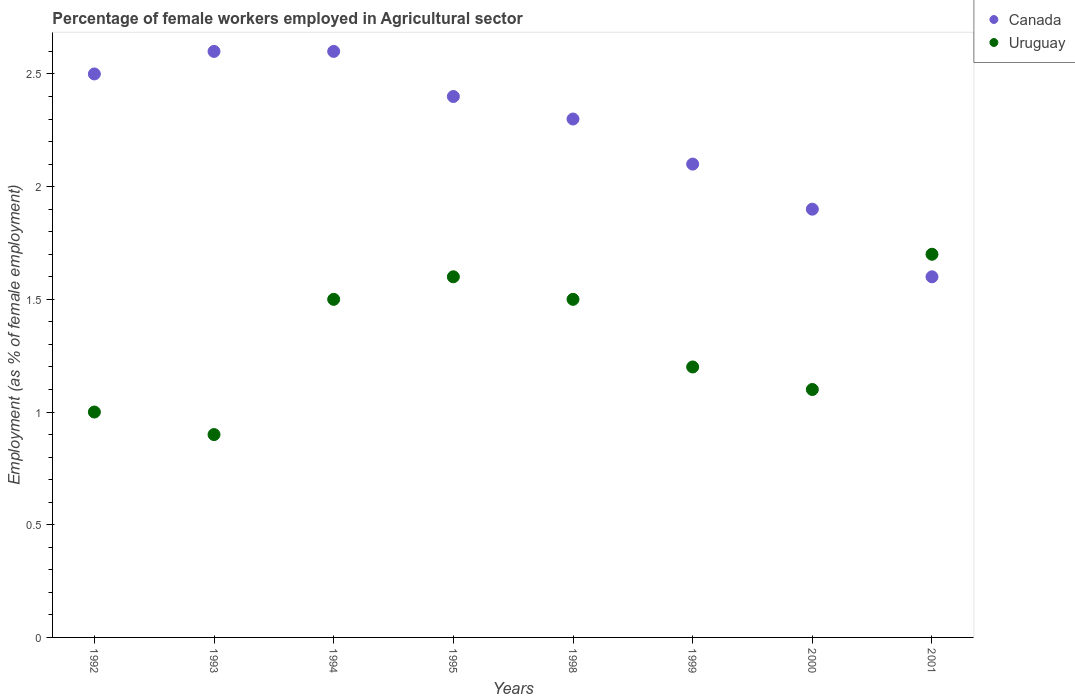What is the percentage of females employed in Agricultural sector in Uruguay in 1992?
Provide a succinct answer. 1. Across all years, what is the maximum percentage of females employed in Agricultural sector in Uruguay?
Give a very brief answer. 1.7. Across all years, what is the minimum percentage of females employed in Agricultural sector in Uruguay?
Give a very brief answer. 0.9. In which year was the percentage of females employed in Agricultural sector in Canada maximum?
Offer a very short reply. 1993. What is the total percentage of females employed in Agricultural sector in Uruguay in the graph?
Make the answer very short. 10.5. What is the difference between the percentage of females employed in Agricultural sector in Uruguay in 1994 and that in 2001?
Ensure brevity in your answer.  -0.2. What is the difference between the percentage of females employed in Agricultural sector in Canada in 1994 and the percentage of females employed in Agricultural sector in Uruguay in 2001?
Keep it short and to the point. 0.9. What is the average percentage of females employed in Agricultural sector in Canada per year?
Your response must be concise. 2.25. In the year 1993, what is the difference between the percentage of females employed in Agricultural sector in Canada and percentage of females employed in Agricultural sector in Uruguay?
Give a very brief answer. 1.7. What is the ratio of the percentage of females employed in Agricultural sector in Canada in 1995 to that in 2000?
Your response must be concise. 1.26. Is the percentage of females employed in Agricultural sector in Uruguay in 1992 less than that in 1995?
Your response must be concise. Yes. Is the difference between the percentage of females employed in Agricultural sector in Canada in 1999 and 2000 greater than the difference between the percentage of females employed in Agricultural sector in Uruguay in 1999 and 2000?
Your answer should be compact. Yes. What is the difference between the highest and the second highest percentage of females employed in Agricultural sector in Canada?
Make the answer very short. 0. What is the difference between the highest and the lowest percentage of females employed in Agricultural sector in Uruguay?
Provide a short and direct response. 0.8. Is the sum of the percentage of females employed in Agricultural sector in Canada in 1999 and 2001 greater than the maximum percentage of females employed in Agricultural sector in Uruguay across all years?
Offer a terse response. Yes. Does the percentage of females employed in Agricultural sector in Uruguay monotonically increase over the years?
Your response must be concise. No. Is the percentage of females employed in Agricultural sector in Canada strictly greater than the percentage of females employed in Agricultural sector in Uruguay over the years?
Offer a terse response. No. How many dotlines are there?
Make the answer very short. 2. Are the values on the major ticks of Y-axis written in scientific E-notation?
Your response must be concise. No. Does the graph contain grids?
Your answer should be very brief. No. Where does the legend appear in the graph?
Your answer should be very brief. Top right. How many legend labels are there?
Provide a short and direct response. 2. How are the legend labels stacked?
Keep it short and to the point. Vertical. What is the title of the graph?
Your response must be concise. Percentage of female workers employed in Agricultural sector. What is the label or title of the Y-axis?
Give a very brief answer. Employment (as % of female employment). What is the Employment (as % of female employment) of Canada in 1993?
Provide a short and direct response. 2.6. What is the Employment (as % of female employment) in Uruguay in 1993?
Provide a succinct answer. 0.9. What is the Employment (as % of female employment) in Canada in 1994?
Your response must be concise. 2.6. What is the Employment (as % of female employment) in Uruguay in 1994?
Your answer should be compact. 1.5. What is the Employment (as % of female employment) of Canada in 1995?
Provide a succinct answer. 2.4. What is the Employment (as % of female employment) of Uruguay in 1995?
Offer a terse response. 1.6. What is the Employment (as % of female employment) of Canada in 1998?
Provide a short and direct response. 2.3. What is the Employment (as % of female employment) of Uruguay in 1998?
Your answer should be compact. 1.5. What is the Employment (as % of female employment) of Canada in 1999?
Make the answer very short. 2.1. What is the Employment (as % of female employment) of Uruguay in 1999?
Provide a short and direct response. 1.2. What is the Employment (as % of female employment) of Canada in 2000?
Your answer should be compact. 1.9. What is the Employment (as % of female employment) in Uruguay in 2000?
Offer a terse response. 1.1. What is the Employment (as % of female employment) of Canada in 2001?
Provide a short and direct response. 1.6. What is the Employment (as % of female employment) in Uruguay in 2001?
Ensure brevity in your answer.  1.7. Across all years, what is the maximum Employment (as % of female employment) in Canada?
Keep it short and to the point. 2.6. Across all years, what is the maximum Employment (as % of female employment) of Uruguay?
Ensure brevity in your answer.  1.7. Across all years, what is the minimum Employment (as % of female employment) of Canada?
Your answer should be compact. 1.6. Across all years, what is the minimum Employment (as % of female employment) in Uruguay?
Your answer should be very brief. 0.9. What is the total Employment (as % of female employment) of Uruguay in the graph?
Give a very brief answer. 10.5. What is the difference between the Employment (as % of female employment) in Uruguay in 1992 and that in 1993?
Your answer should be compact. 0.1. What is the difference between the Employment (as % of female employment) in Uruguay in 1992 and that in 1994?
Keep it short and to the point. -0.5. What is the difference between the Employment (as % of female employment) in Canada in 1992 and that in 1995?
Your answer should be compact. 0.1. What is the difference between the Employment (as % of female employment) in Uruguay in 1992 and that in 1995?
Your answer should be compact. -0.6. What is the difference between the Employment (as % of female employment) of Uruguay in 1992 and that in 1999?
Offer a very short reply. -0.2. What is the difference between the Employment (as % of female employment) of Uruguay in 1992 and that in 2001?
Your answer should be compact. -0.7. What is the difference between the Employment (as % of female employment) in Canada in 1993 and that in 1994?
Your answer should be compact. 0. What is the difference between the Employment (as % of female employment) of Uruguay in 1993 and that in 1994?
Keep it short and to the point. -0.6. What is the difference between the Employment (as % of female employment) of Canada in 1993 and that in 1995?
Keep it short and to the point. 0.2. What is the difference between the Employment (as % of female employment) in Uruguay in 1993 and that in 1995?
Give a very brief answer. -0.7. What is the difference between the Employment (as % of female employment) of Canada in 1993 and that in 1998?
Your answer should be compact. 0.3. What is the difference between the Employment (as % of female employment) of Canada in 1993 and that in 1999?
Offer a very short reply. 0.5. What is the difference between the Employment (as % of female employment) of Canada in 1993 and that in 2001?
Ensure brevity in your answer.  1. What is the difference between the Employment (as % of female employment) of Canada in 1994 and that in 1995?
Keep it short and to the point. 0.2. What is the difference between the Employment (as % of female employment) of Uruguay in 1994 and that in 1995?
Provide a short and direct response. -0.1. What is the difference between the Employment (as % of female employment) of Uruguay in 1994 and that in 1998?
Your answer should be very brief. 0. What is the difference between the Employment (as % of female employment) in Uruguay in 1994 and that in 1999?
Your response must be concise. 0.3. What is the difference between the Employment (as % of female employment) in Canada in 1994 and that in 2000?
Keep it short and to the point. 0.7. What is the difference between the Employment (as % of female employment) in Uruguay in 1994 and that in 2000?
Provide a short and direct response. 0.4. What is the difference between the Employment (as % of female employment) in Canada in 1995 and that in 1999?
Provide a short and direct response. 0.3. What is the difference between the Employment (as % of female employment) of Uruguay in 1995 and that in 1999?
Ensure brevity in your answer.  0.4. What is the difference between the Employment (as % of female employment) in Uruguay in 1995 and that in 2001?
Offer a terse response. -0.1. What is the difference between the Employment (as % of female employment) of Canada in 1998 and that in 1999?
Give a very brief answer. 0.2. What is the difference between the Employment (as % of female employment) of Uruguay in 1998 and that in 1999?
Your answer should be compact. 0.3. What is the difference between the Employment (as % of female employment) in Uruguay in 1998 and that in 2001?
Provide a succinct answer. -0.2. What is the difference between the Employment (as % of female employment) in Canada in 1999 and that in 2000?
Your answer should be compact. 0.2. What is the difference between the Employment (as % of female employment) of Uruguay in 1999 and that in 2000?
Your response must be concise. 0.1. What is the difference between the Employment (as % of female employment) in Canada in 1999 and that in 2001?
Give a very brief answer. 0.5. What is the difference between the Employment (as % of female employment) of Uruguay in 1999 and that in 2001?
Offer a very short reply. -0.5. What is the difference between the Employment (as % of female employment) of Canada in 2000 and that in 2001?
Provide a succinct answer. 0.3. What is the difference between the Employment (as % of female employment) in Canada in 1992 and the Employment (as % of female employment) in Uruguay in 1994?
Your answer should be compact. 1. What is the difference between the Employment (as % of female employment) in Canada in 1992 and the Employment (as % of female employment) in Uruguay in 1999?
Your response must be concise. 1.3. What is the difference between the Employment (as % of female employment) in Canada in 1992 and the Employment (as % of female employment) in Uruguay in 2000?
Keep it short and to the point. 1.4. What is the difference between the Employment (as % of female employment) of Canada in 1993 and the Employment (as % of female employment) of Uruguay in 1998?
Your answer should be compact. 1.1. What is the difference between the Employment (as % of female employment) in Canada in 1993 and the Employment (as % of female employment) in Uruguay in 1999?
Your answer should be compact. 1.4. What is the difference between the Employment (as % of female employment) of Canada in 1994 and the Employment (as % of female employment) of Uruguay in 1998?
Offer a very short reply. 1.1. What is the difference between the Employment (as % of female employment) in Canada in 1995 and the Employment (as % of female employment) in Uruguay in 2000?
Provide a short and direct response. 1.3. What is the difference between the Employment (as % of female employment) in Canada in 1995 and the Employment (as % of female employment) in Uruguay in 2001?
Keep it short and to the point. 0.7. What is the difference between the Employment (as % of female employment) of Canada in 1998 and the Employment (as % of female employment) of Uruguay in 1999?
Offer a very short reply. 1.1. What is the difference between the Employment (as % of female employment) in Canada in 1998 and the Employment (as % of female employment) in Uruguay in 2000?
Provide a short and direct response. 1.2. What is the difference between the Employment (as % of female employment) in Canada in 1999 and the Employment (as % of female employment) in Uruguay in 2000?
Your answer should be very brief. 1. What is the difference between the Employment (as % of female employment) in Canada in 1999 and the Employment (as % of female employment) in Uruguay in 2001?
Your answer should be very brief. 0.4. What is the difference between the Employment (as % of female employment) in Canada in 2000 and the Employment (as % of female employment) in Uruguay in 2001?
Your response must be concise. 0.2. What is the average Employment (as % of female employment) of Canada per year?
Your answer should be compact. 2.25. What is the average Employment (as % of female employment) in Uruguay per year?
Make the answer very short. 1.31. In the year 1993, what is the difference between the Employment (as % of female employment) in Canada and Employment (as % of female employment) in Uruguay?
Offer a very short reply. 1.7. In the year 2000, what is the difference between the Employment (as % of female employment) of Canada and Employment (as % of female employment) of Uruguay?
Your answer should be compact. 0.8. What is the ratio of the Employment (as % of female employment) in Canada in 1992 to that in 1993?
Your answer should be compact. 0.96. What is the ratio of the Employment (as % of female employment) of Uruguay in 1992 to that in 1993?
Make the answer very short. 1.11. What is the ratio of the Employment (as % of female employment) of Canada in 1992 to that in 1994?
Your answer should be compact. 0.96. What is the ratio of the Employment (as % of female employment) of Canada in 1992 to that in 1995?
Offer a very short reply. 1.04. What is the ratio of the Employment (as % of female employment) in Uruguay in 1992 to that in 1995?
Your answer should be very brief. 0.62. What is the ratio of the Employment (as % of female employment) of Canada in 1992 to that in 1998?
Your answer should be very brief. 1.09. What is the ratio of the Employment (as % of female employment) of Uruguay in 1992 to that in 1998?
Your answer should be very brief. 0.67. What is the ratio of the Employment (as % of female employment) of Canada in 1992 to that in 1999?
Your answer should be compact. 1.19. What is the ratio of the Employment (as % of female employment) of Canada in 1992 to that in 2000?
Provide a short and direct response. 1.32. What is the ratio of the Employment (as % of female employment) in Uruguay in 1992 to that in 2000?
Your answer should be compact. 0.91. What is the ratio of the Employment (as % of female employment) of Canada in 1992 to that in 2001?
Offer a terse response. 1.56. What is the ratio of the Employment (as % of female employment) in Uruguay in 1992 to that in 2001?
Your response must be concise. 0.59. What is the ratio of the Employment (as % of female employment) in Canada in 1993 to that in 1994?
Make the answer very short. 1. What is the ratio of the Employment (as % of female employment) in Uruguay in 1993 to that in 1994?
Your answer should be very brief. 0.6. What is the ratio of the Employment (as % of female employment) of Canada in 1993 to that in 1995?
Ensure brevity in your answer.  1.08. What is the ratio of the Employment (as % of female employment) of Uruguay in 1993 to that in 1995?
Keep it short and to the point. 0.56. What is the ratio of the Employment (as % of female employment) of Canada in 1993 to that in 1998?
Your answer should be very brief. 1.13. What is the ratio of the Employment (as % of female employment) of Uruguay in 1993 to that in 1998?
Give a very brief answer. 0.6. What is the ratio of the Employment (as % of female employment) in Canada in 1993 to that in 1999?
Offer a terse response. 1.24. What is the ratio of the Employment (as % of female employment) of Canada in 1993 to that in 2000?
Provide a short and direct response. 1.37. What is the ratio of the Employment (as % of female employment) of Uruguay in 1993 to that in 2000?
Your response must be concise. 0.82. What is the ratio of the Employment (as % of female employment) in Canada in 1993 to that in 2001?
Your answer should be very brief. 1.62. What is the ratio of the Employment (as % of female employment) in Uruguay in 1993 to that in 2001?
Provide a short and direct response. 0.53. What is the ratio of the Employment (as % of female employment) in Canada in 1994 to that in 1998?
Keep it short and to the point. 1.13. What is the ratio of the Employment (as % of female employment) in Canada in 1994 to that in 1999?
Provide a short and direct response. 1.24. What is the ratio of the Employment (as % of female employment) in Uruguay in 1994 to that in 1999?
Provide a short and direct response. 1.25. What is the ratio of the Employment (as % of female employment) of Canada in 1994 to that in 2000?
Keep it short and to the point. 1.37. What is the ratio of the Employment (as % of female employment) in Uruguay in 1994 to that in 2000?
Your response must be concise. 1.36. What is the ratio of the Employment (as % of female employment) in Canada in 1994 to that in 2001?
Offer a terse response. 1.62. What is the ratio of the Employment (as % of female employment) of Uruguay in 1994 to that in 2001?
Ensure brevity in your answer.  0.88. What is the ratio of the Employment (as % of female employment) of Canada in 1995 to that in 1998?
Provide a short and direct response. 1.04. What is the ratio of the Employment (as % of female employment) of Uruguay in 1995 to that in 1998?
Ensure brevity in your answer.  1.07. What is the ratio of the Employment (as % of female employment) of Uruguay in 1995 to that in 1999?
Ensure brevity in your answer.  1.33. What is the ratio of the Employment (as % of female employment) of Canada in 1995 to that in 2000?
Your response must be concise. 1.26. What is the ratio of the Employment (as % of female employment) of Uruguay in 1995 to that in 2000?
Keep it short and to the point. 1.45. What is the ratio of the Employment (as % of female employment) in Canada in 1995 to that in 2001?
Provide a succinct answer. 1.5. What is the ratio of the Employment (as % of female employment) in Uruguay in 1995 to that in 2001?
Make the answer very short. 0.94. What is the ratio of the Employment (as % of female employment) in Canada in 1998 to that in 1999?
Ensure brevity in your answer.  1.1. What is the ratio of the Employment (as % of female employment) of Canada in 1998 to that in 2000?
Provide a short and direct response. 1.21. What is the ratio of the Employment (as % of female employment) of Uruguay in 1998 to that in 2000?
Your answer should be compact. 1.36. What is the ratio of the Employment (as % of female employment) in Canada in 1998 to that in 2001?
Your answer should be compact. 1.44. What is the ratio of the Employment (as % of female employment) of Uruguay in 1998 to that in 2001?
Offer a very short reply. 0.88. What is the ratio of the Employment (as % of female employment) in Canada in 1999 to that in 2000?
Provide a succinct answer. 1.11. What is the ratio of the Employment (as % of female employment) of Uruguay in 1999 to that in 2000?
Make the answer very short. 1.09. What is the ratio of the Employment (as % of female employment) of Canada in 1999 to that in 2001?
Your answer should be compact. 1.31. What is the ratio of the Employment (as % of female employment) in Uruguay in 1999 to that in 2001?
Your response must be concise. 0.71. What is the ratio of the Employment (as % of female employment) in Canada in 2000 to that in 2001?
Ensure brevity in your answer.  1.19. What is the ratio of the Employment (as % of female employment) in Uruguay in 2000 to that in 2001?
Make the answer very short. 0.65. What is the difference between the highest and the second highest Employment (as % of female employment) in Uruguay?
Your answer should be compact. 0.1. What is the difference between the highest and the lowest Employment (as % of female employment) of Canada?
Make the answer very short. 1. What is the difference between the highest and the lowest Employment (as % of female employment) of Uruguay?
Provide a succinct answer. 0.8. 